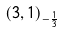<formula> <loc_0><loc_0><loc_500><loc_500>( 3 , 1 ) _ { - { \frac { 1 } { 3 } } }</formula> 